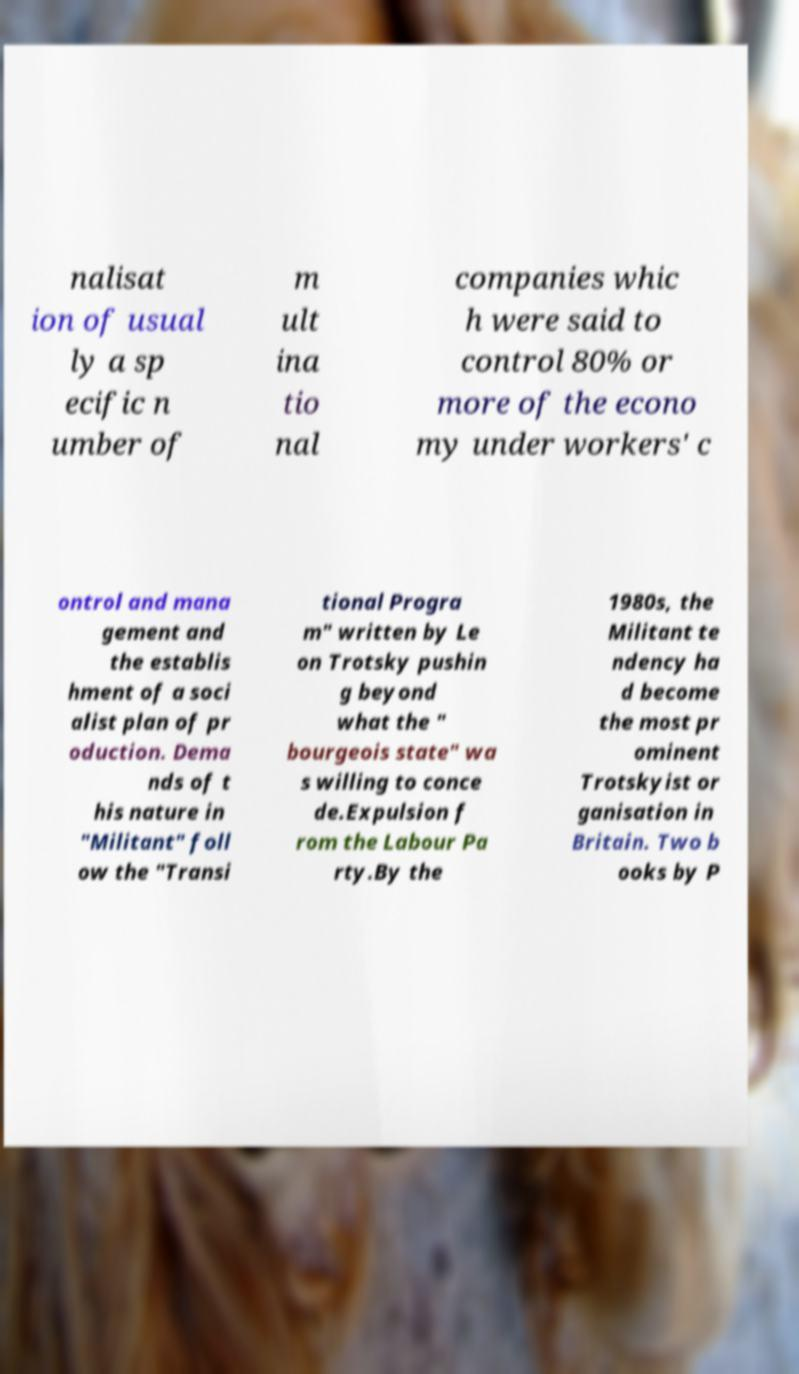I need the written content from this picture converted into text. Can you do that? nalisat ion of usual ly a sp ecific n umber of m ult ina tio nal companies whic h were said to control 80% or more of the econo my under workers' c ontrol and mana gement and the establis hment of a soci alist plan of pr oduction. Dema nds of t his nature in "Militant" foll ow the "Transi tional Progra m" written by Le on Trotsky pushin g beyond what the " bourgeois state" wa s willing to conce de.Expulsion f rom the Labour Pa rty.By the 1980s, the Militant te ndency ha d become the most pr ominent Trotskyist or ganisation in Britain. Two b ooks by P 